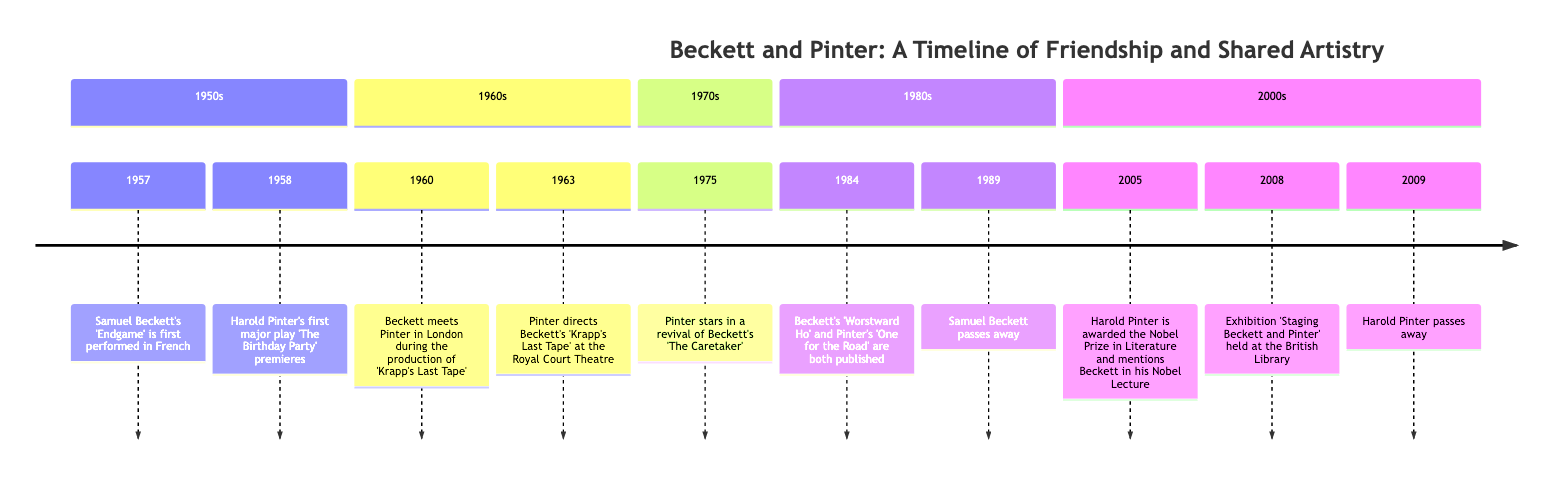What year was 'Endgame' first performed? According to the timeline, 'Endgame' by Samuel Beckett was first performed in 1957. The date is explicitly stated in the first node of the timeline.
Answer: 1957 What major play did Harold Pinter premiere in 1958? The timeline indicates that Harold Pinter's first major play, 'The Birthday Party', premiered in 1958. This information is presented in the second node under the 1950s section.
Answer: The Birthday Party In what year did Beckett and Pinter first meet? The timeline records that Beckett met Pinter in 1960 during the production of 'Krapp's Last Tape'. This detail can be found in the 1960 entry of the diagram.
Answer: 1960 Who directed Beckett's 'Krapp's Last Tape' at the Royal Court Theatre? The timeline shows that Pinter directed Beckett's 'Krapp's Last Tape' in 1963. This information is contained within the events listed for the 1960s.
Answer: Pinter What happened in 1984 regarding both authors? The timeline specifies that in 1984, Beckett's 'Worstward Ho' and Pinter's 'One for the Road' were both published. This information is located in the 1980s section of the diagram, indicating a significant overlap in their artistic timelines.
Answer: Publication of works What major event did Harold Pinter receive in 2005, and what did he mention in relation to Beckett? The timeline states that Harold Pinter was awarded the Nobel Prize in Literature in 2005, and he mentioned Beckett in his Nobel Lecture. This is noted in the 2000s section of the timeline.
Answer: Nobel Prize In what year did both Beckett and Pinter pass away? According to the timeline, Samuel Beckett passed away in 1989 and Harold Pinter in 2009. The question asks for the years of their deaths, which can be found in the respective entries in the timeline.
Answer: 1989 and 2009 What significant exhibition was held in 2008 related to both authors? The timeline indicates that in 2008, there was an exhibition titled 'Staging Beckett and Pinter' held at the British Library to commemorate their works. This event is specifically noted in the 2000s section.
Answer: Staging Beckett and Pinter How many years apart did Beckett and Pinter die? The timeline shows Beckett died in 1989 and Pinter in 2009. To find the difference in years, subtract 1989 from 2009, leading to a total of 20 years apart.
Answer: 20 years 